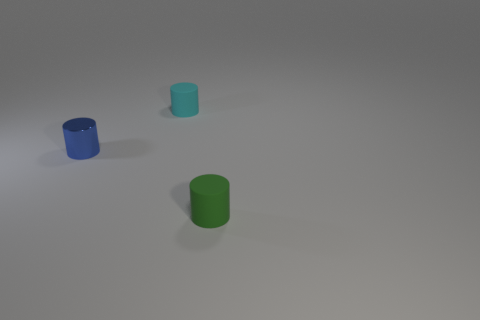Add 2 big green cubes. How many objects exist? 5 Add 3 small metal things. How many small metal things are left? 4 Add 3 small cylinders. How many small cylinders exist? 6 Subtract 0 yellow balls. How many objects are left? 3 Subtract all tiny blue metal cylinders. Subtract all small cyan objects. How many objects are left? 1 